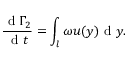<formula> <loc_0><loc_0><loc_500><loc_500>\frac { d \Gamma _ { 2 } } { d t } = \int _ { l } \omega u ( y ) d y .</formula> 